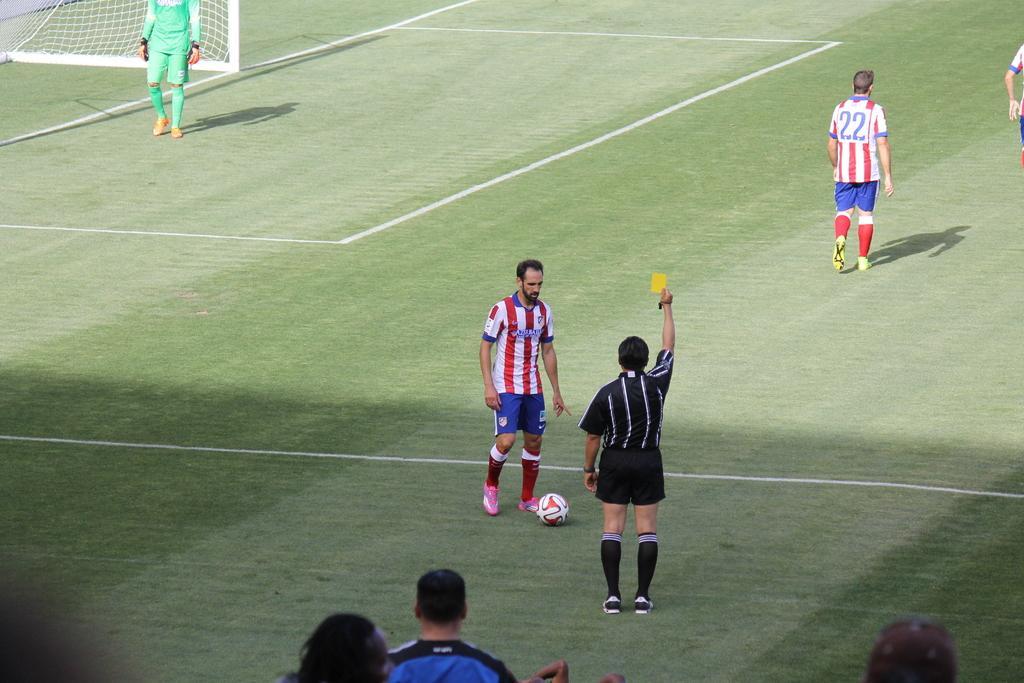How would you summarize this image in a sentence or two? In the picture we can see a playground on it, we can see some people are in sports wear and a football on the ground and we can also see a net. 